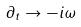<formula> <loc_0><loc_0><loc_500><loc_500>\partial _ { t } \rightarrow - i \omega</formula> 